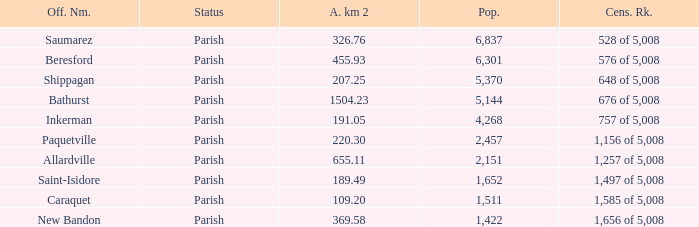What is the Area of the Saint-Isidore Parish with a Population smaller than 4,268? 189.49. 